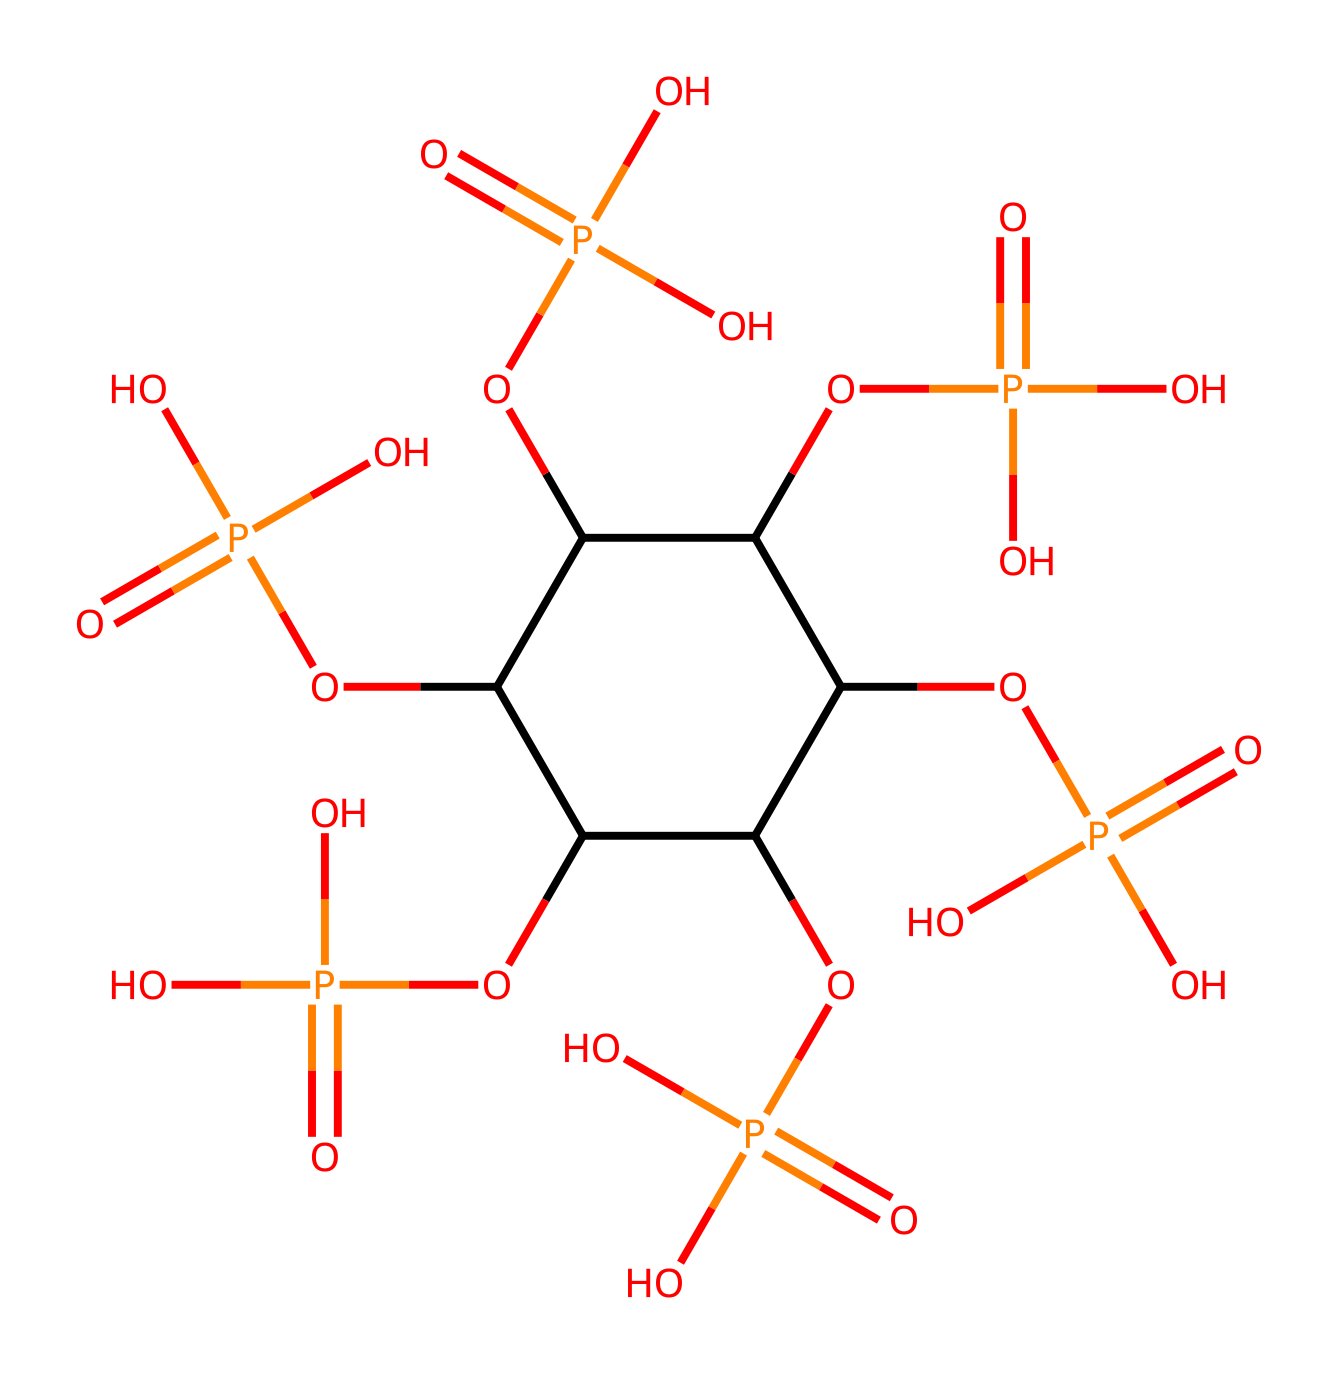What is the molecular formula of phytic acid? By analyzing the chemical structure represented by the provided SMILES, we can identify the components. The structure reveals several carbon (C), hydrogen (H), oxygen (O), and phosphorus (P) atoms. Count the atoms in the structure for the molecular formula.
Answer: C6H18O24P6 How many phosphate groups are present in phytic acid? Within the chemical structure, we can see that there are multiple OP(=O)(O)O groups. Each of these represents a phosphate group. Counting them gives us the total number of phosphate groups in phytic acid.
Answer: 6 What type of chemical compound is phytic acid classified as? Phytic acid contains phosphorus and exhibits properties typical of organic phosphates and is often categorized under the larger classification of phosphorus compounds. The presence of multiple phosphate groups identifies it specifically as a phosphoric acid derivative.
Answer: phosphoric acid What is the total number of carbon atoms in the structure? Reviewing the SMILES representation, we can count the number of distinct carbon atoms denoted by "C". There are multiple "C" representations indicating the total number of carbon atoms.
Answer: 6 What functional groups characterize phytic acid? The SMILES representation shows several phosphate groups (OP(=O)(O)O) attached to a carbon backbone. The presence of these phosphate groups indicates that phytic acid possesses functional groups that are characteristic of phosphoric acid derivatives.
Answer: phosphate groups How many hydrogen atoms are bonded to carbon in phytic acid? By closely inspecting the structure, we account for the hydrogen atoms bonded to carbon based on typical bonding patterns around carbon atoms with single bonds. The total hydrogen atoms connected to carbon reveal the saturation.
Answer: 18 